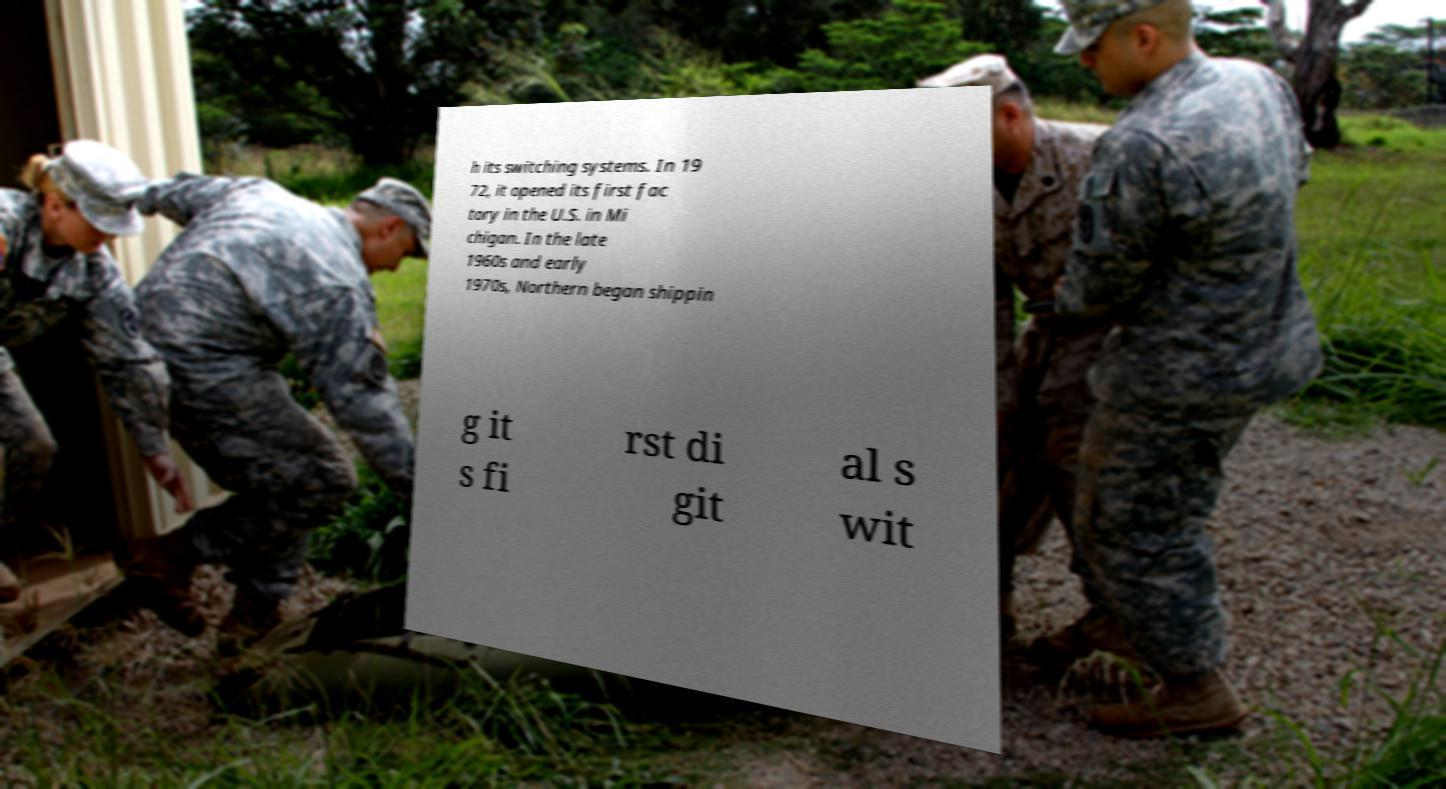Please identify and transcribe the text found in this image. h its switching systems. In 19 72, it opened its first fac tory in the U.S. in Mi chigan. In the late 1960s and early 1970s, Northern began shippin g it s fi rst di git al s wit 